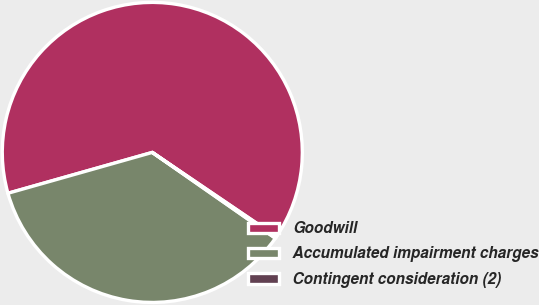Convert chart. <chart><loc_0><loc_0><loc_500><loc_500><pie_chart><fcel>Goodwill<fcel>Accumulated impairment charges<fcel>Contingent consideration (2)<nl><fcel>63.88%<fcel>35.92%<fcel>0.2%<nl></chart> 